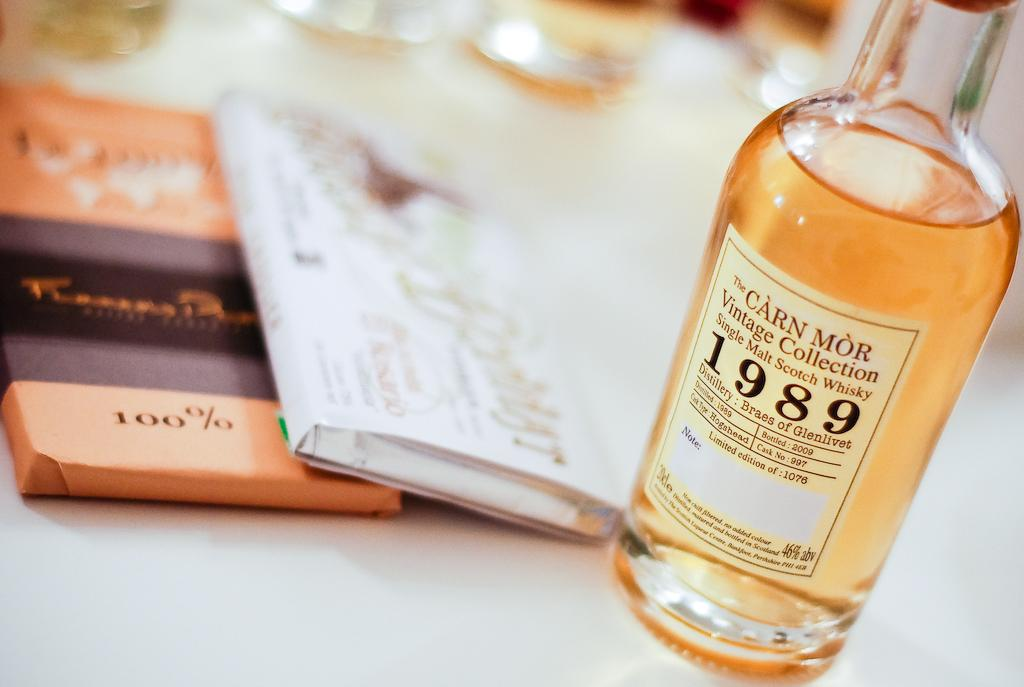Provide a one-sentence caption for the provided image. A Vintage Collection bottle of Scotch Whisky 1989 sits on a table. 